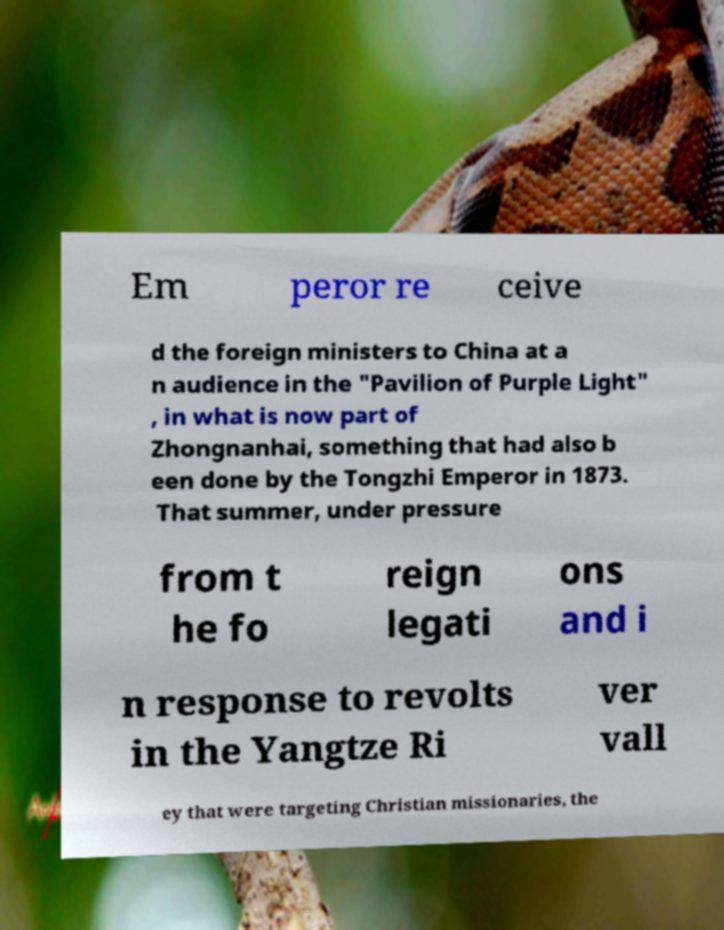Please read and relay the text visible in this image. What does it say? Em peror re ceive d the foreign ministers to China at a n audience in the "Pavilion of Purple Light" , in what is now part of Zhongnanhai, something that had also b een done by the Tongzhi Emperor in 1873. That summer, under pressure from t he fo reign legati ons and i n response to revolts in the Yangtze Ri ver vall ey that were targeting Christian missionaries, the 